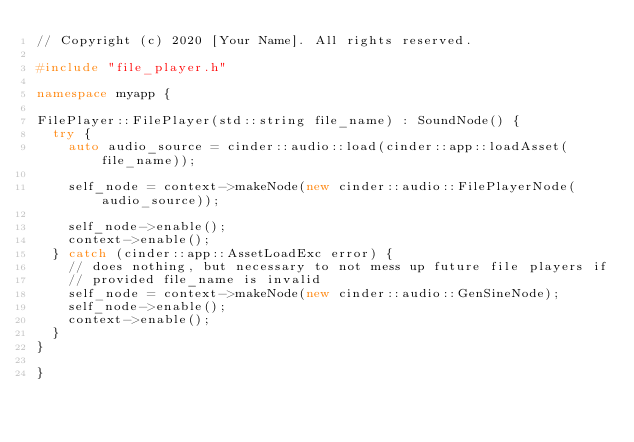Convert code to text. <code><loc_0><loc_0><loc_500><loc_500><_C++_>// Copyright (c) 2020 [Your Name]. All rights reserved.

#include "file_player.h"

namespace myapp {

FilePlayer::FilePlayer(std::string file_name) : SoundNode() {
  try {
    auto audio_source = cinder::audio::load(cinder::app::loadAsset(file_name));

    self_node = context->makeNode(new cinder::audio::FilePlayerNode(audio_source));

    self_node->enable();
    context->enable();
  } catch (cinder::app::AssetLoadExc error) {
    // does nothing, but necessary to not mess up future file players if
    // provided file_name is invalid
    self_node = context->makeNode(new cinder::audio::GenSineNode);
    self_node->enable();
    context->enable();
  }
}

}</code> 